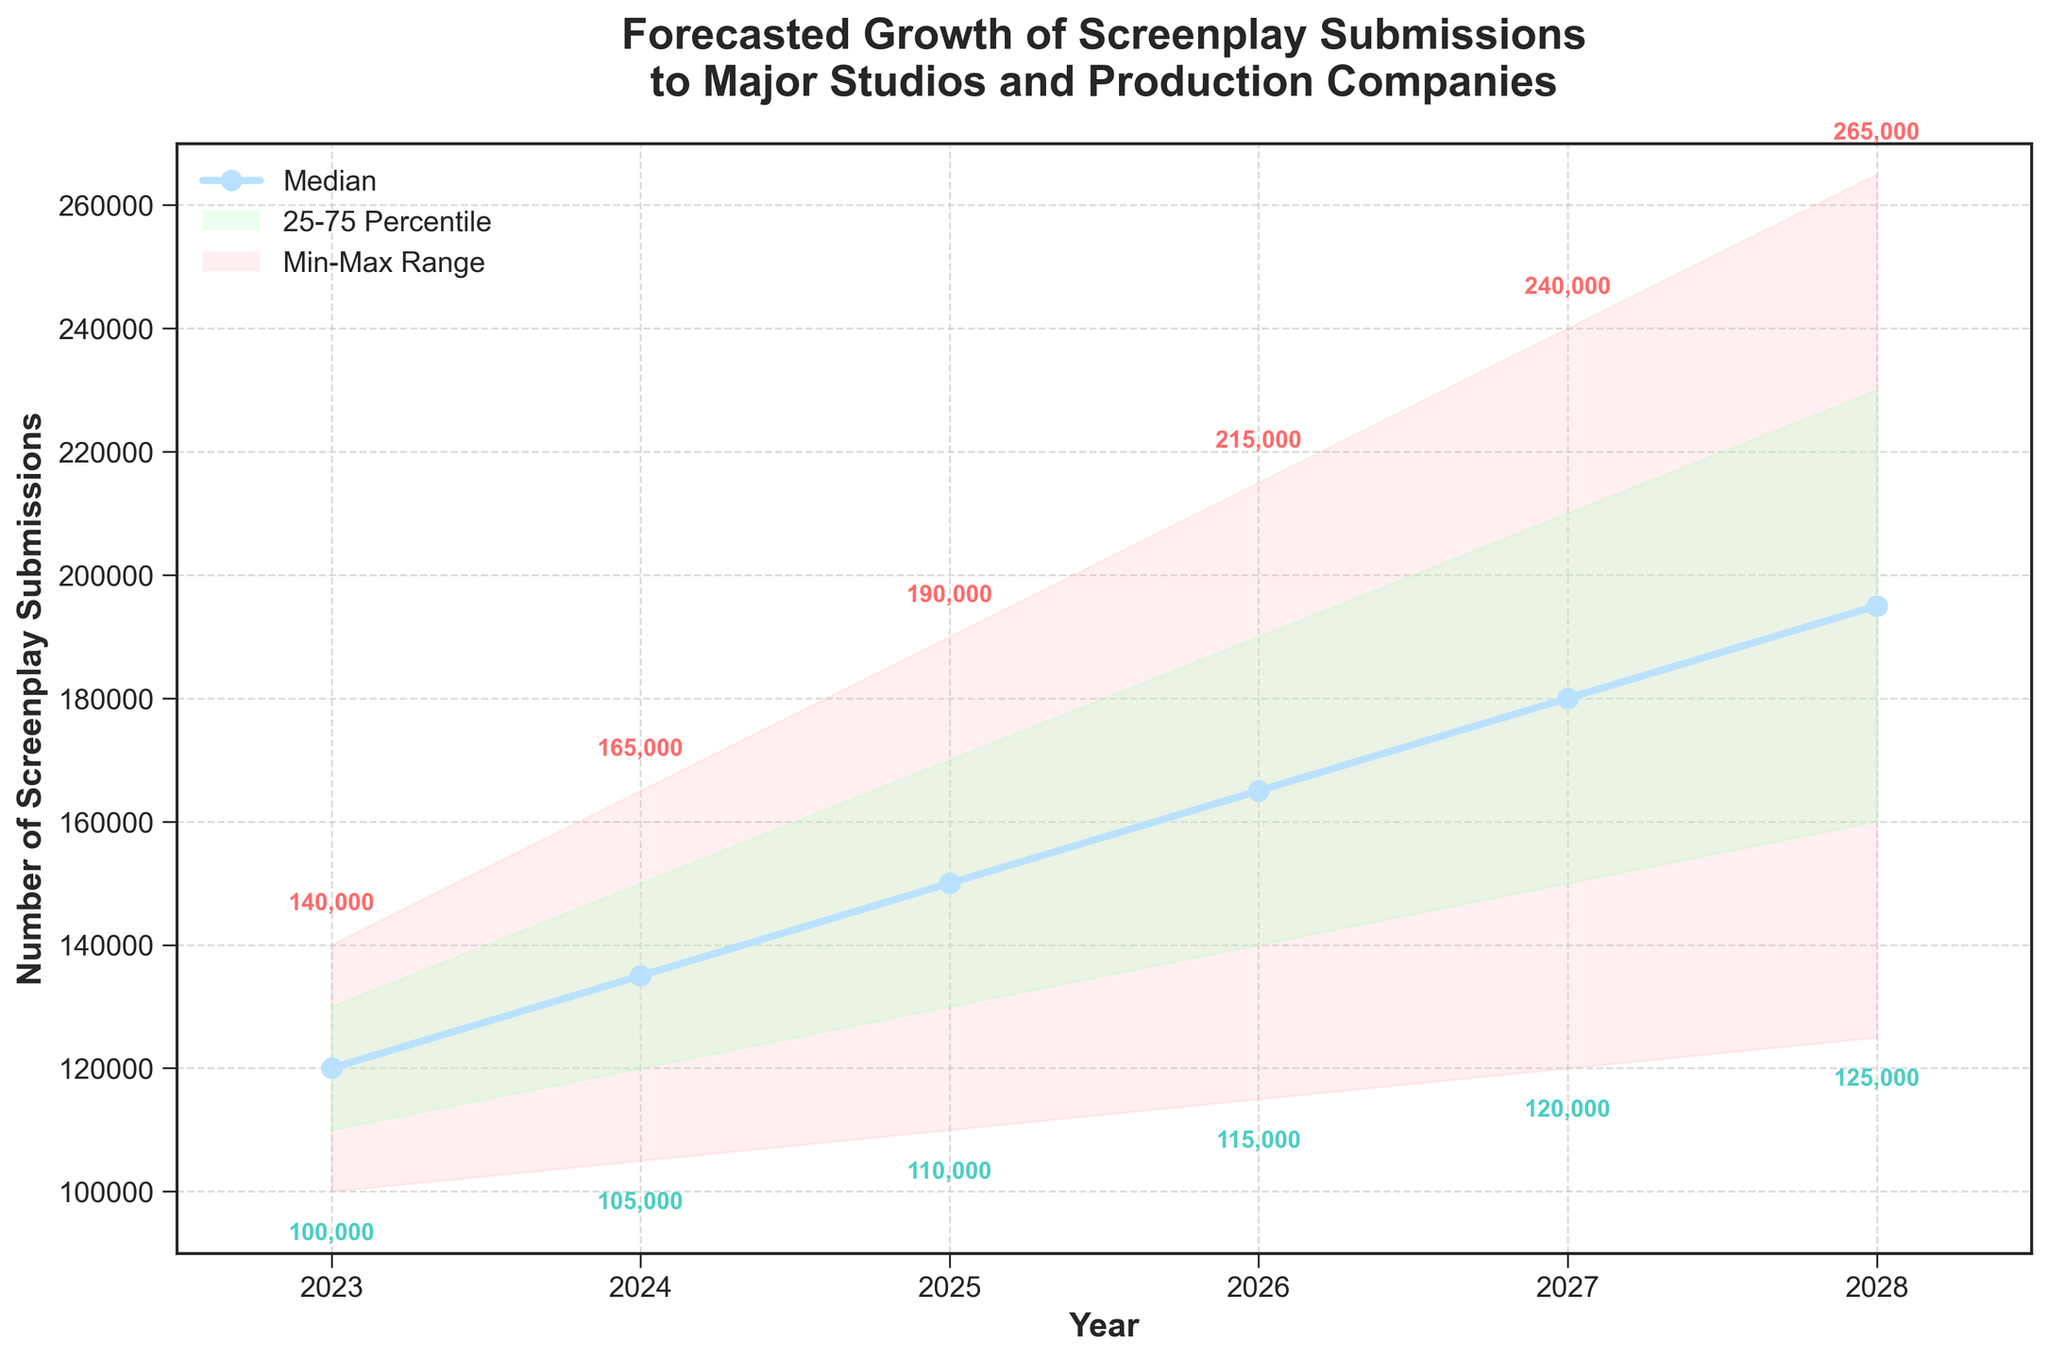what is the title of the plot? The title of the plot is located at the top of the figure, and it reads "Forecasted Growth of Screenplay Submissions to Major Studios and Production Companies".
Answer: Forecasted Growth of Screenplay Submissions to Major Studios and Production Companies How many years are represented in the figure? By looking at the x-axis, you can count that there are years from 2023 to 2028, inclusive, making it six years in total.
Answer: Six What is the median forecasted number of screenplay submissions in 2026? The median forecasted number corresponds to the 'Mid' value for the year 2026. In this case, the data shows it as 165,000 submissions.
Answer: 165,000 In which year is the highest forecasted range (from the lowest to the highest submission) observed? To find this, compare the ranges for each year. In 2028, the range is 265,000 - 125,000 = 140,000, which is the highest among all years.
Answer: 2028 What is the lowest forecasted number of screenplay submissions in 2024? To find the lowest forecasted number in 2024, refer to the 'Low' value for that year in the data, which is 105,000 submissions.
Answer: 105,000 How does the number of submissions in the median forecast change from 2023 to 2025? The median forecast numbers for 2023 and 2025 are 120,000 and 150,000, respectively. The change is calculated as 150,000 - 120,000 = 30,000.
Answer: 30,000 increase Is the 75th percentile of the forecast greater than the median in 2027? The 75th percentile in 2027 is represented by the 'Mid-High' value, which is 210,000, and the median is 180,000. Since 210,000 > 180,000, the answer is yes.
Answer: Yes Which year shows the smallest value in the lowest forecasted submissions? By examining the 'Low' values for all years, 2023 has the smallest value at 100,000.
Answer: 2023 What is the range of screenplay submissions for the year 2025? The range can be found by subtracting the 'Low' value from the 'High' value for 2025. The range is 190,000 - 110,000 = 80,000.
Answer: 80,000 